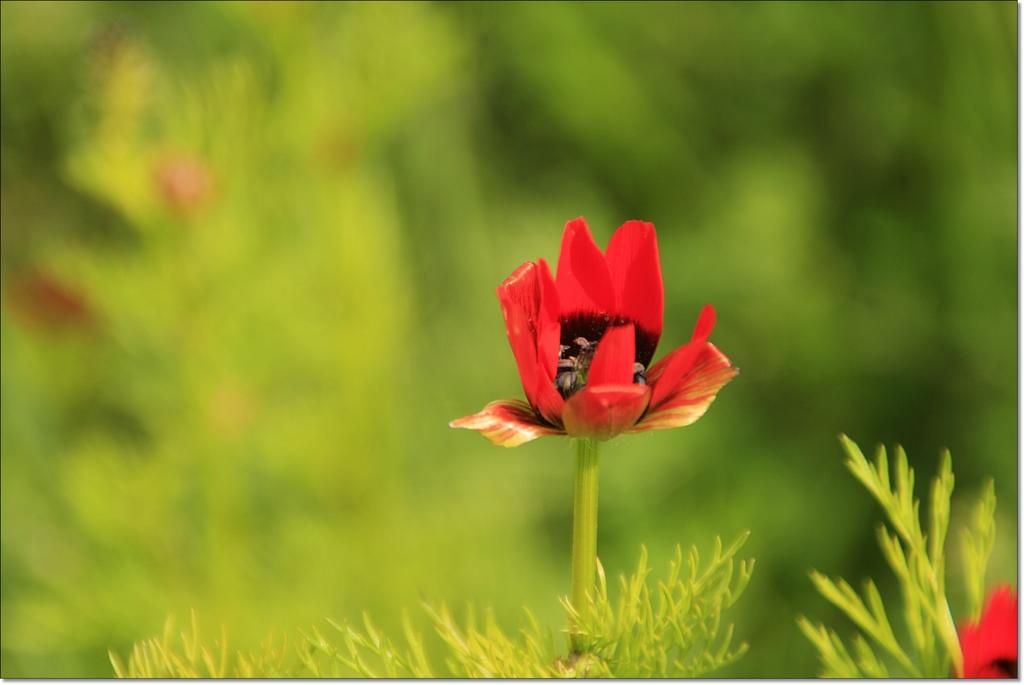What is present in the image? There are flowers in the image. Can you describe the background of the image? The background of the image is blurred. What is the temperature of the road in the image? There is no road present in the image, so it is not possible to determine the temperature. 